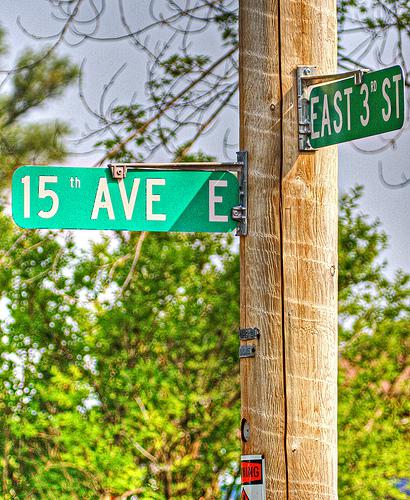Question: what is on the pole?
Choices:
A. Street signs.
B. A flag.
C. A stop light.
D. An advertisement.
Answer with the letter. Answer: A Question: how many street signs are on the pole?
Choices:
A. One.
B. None.
C. Two.
D. Three.
Answer with the letter. Answer: C Question: what color are the street signs?
Choices:
A. Green and white.
B. Blue and white.
C. Red and white.
D. Yellow.
Answer with the letter. Answer: A 